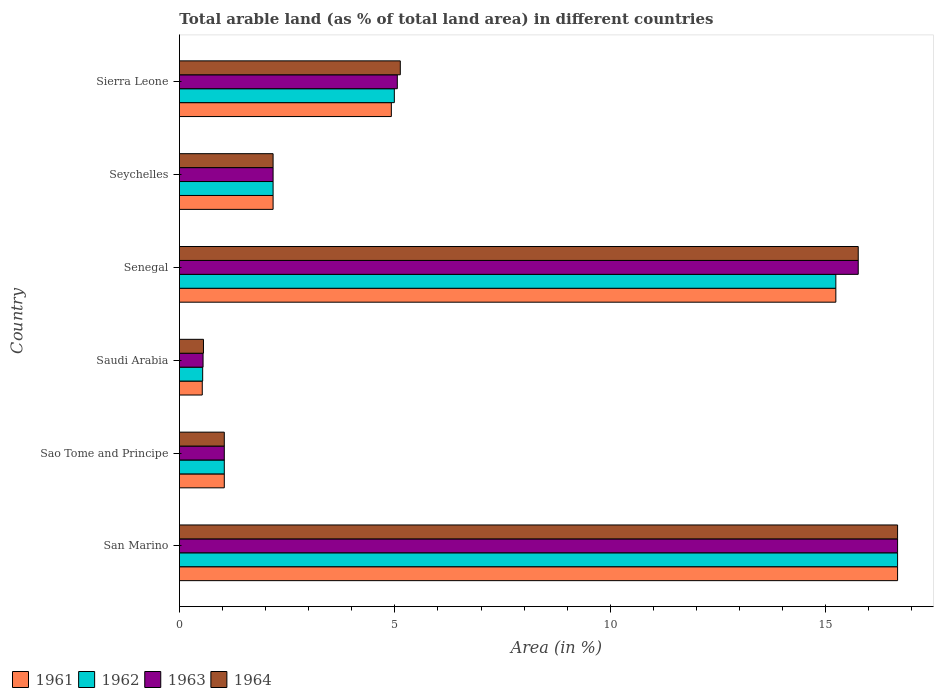How many groups of bars are there?
Your answer should be compact. 6. Are the number of bars per tick equal to the number of legend labels?
Keep it short and to the point. Yes. How many bars are there on the 4th tick from the top?
Keep it short and to the point. 4. What is the label of the 5th group of bars from the top?
Keep it short and to the point. Sao Tome and Principe. In how many cases, is the number of bars for a given country not equal to the number of legend labels?
Offer a very short reply. 0. What is the percentage of arable land in 1961 in Senegal?
Keep it short and to the point. 15.23. Across all countries, what is the maximum percentage of arable land in 1962?
Ensure brevity in your answer.  16.67. Across all countries, what is the minimum percentage of arable land in 1961?
Your answer should be very brief. 0.53. In which country was the percentage of arable land in 1962 maximum?
Ensure brevity in your answer.  San Marino. In which country was the percentage of arable land in 1963 minimum?
Keep it short and to the point. Saudi Arabia. What is the total percentage of arable land in 1964 in the graph?
Offer a very short reply. 41.32. What is the difference between the percentage of arable land in 1964 in Sao Tome and Principe and that in Seychelles?
Make the answer very short. -1.13. What is the difference between the percentage of arable land in 1962 in Sierra Leone and the percentage of arable land in 1964 in Saudi Arabia?
Offer a terse response. 4.43. What is the average percentage of arable land in 1962 per country?
Your answer should be very brief. 6.77. In how many countries, is the percentage of arable land in 1964 greater than 8 %?
Your response must be concise. 2. What is the ratio of the percentage of arable land in 1961 in Saudi Arabia to that in Seychelles?
Provide a short and direct response. 0.24. Is the percentage of arable land in 1961 in San Marino less than that in Seychelles?
Provide a succinct answer. No. Is the difference between the percentage of arable land in 1961 in San Marino and Seychelles greater than the difference between the percentage of arable land in 1964 in San Marino and Seychelles?
Your answer should be very brief. No. What is the difference between the highest and the second highest percentage of arable land in 1963?
Your response must be concise. 0.91. What is the difference between the highest and the lowest percentage of arable land in 1964?
Give a very brief answer. 16.11. In how many countries, is the percentage of arable land in 1961 greater than the average percentage of arable land in 1961 taken over all countries?
Your response must be concise. 2. Is it the case that in every country, the sum of the percentage of arable land in 1961 and percentage of arable land in 1962 is greater than the sum of percentage of arable land in 1963 and percentage of arable land in 1964?
Keep it short and to the point. No. What does the 4th bar from the top in Seychelles represents?
Give a very brief answer. 1961. What does the 4th bar from the bottom in Sierra Leone represents?
Ensure brevity in your answer.  1964. Is it the case that in every country, the sum of the percentage of arable land in 1961 and percentage of arable land in 1963 is greater than the percentage of arable land in 1962?
Your answer should be very brief. Yes. How many bars are there?
Provide a short and direct response. 24. Are all the bars in the graph horizontal?
Make the answer very short. Yes. Does the graph contain any zero values?
Your answer should be very brief. No. Where does the legend appear in the graph?
Your response must be concise. Bottom left. How many legend labels are there?
Offer a terse response. 4. How are the legend labels stacked?
Provide a succinct answer. Horizontal. What is the title of the graph?
Your answer should be compact. Total arable land (as % of total land area) in different countries. Does "1980" appear as one of the legend labels in the graph?
Make the answer very short. No. What is the label or title of the X-axis?
Ensure brevity in your answer.  Area (in %). What is the label or title of the Y-axis?
Keep it short and to the point. Country. What is the Area (in %) of 1961 in San Marino?
Your answer should be very brief. 16.67. What is the Area (in %) of 1962 in San Marino?
Make the answer very short. 16.67. What is the Area (in %) in 1963 in San Marino?
Your response must be concise. 16.67. What is the Area (in %) of 1964 in San Marino?
Give a very brief answer. 16.67. What is the Area (in %) of 1961 in Sao Tome and Principe?
Keep it short and to the point. 1.04. What is the Area (in %) in 1962 in Sao Tome and Principe?
Offer a terse response. 1.04. What is the Area (in %) in 1963 in Sao Tome and Principe?
Provide a short and direct response. 1.04. What is the Area (in %) of 1964 in Sao Tome and Principe?
Ensure brevity in your answer.  1.04. What is the Area (in %) of 1961 in Saudi Arabia?
Your answer should be very brief. 0.53. What is the Area (in %) of 1962 in Saudi Arabia?
Give a very brief answer. 0.54. What is the Area (in %) in 1963 in Saudi Arabia?
Your answer should be compact. 0.55. What is the Area (in %) in 1964 in Saudi Arabia?
Offer a very short reply. 0.56. What is the Area (in %) in 1961 in Senegal?
Provide a succinct answer. 15.23. What is the Area (in %) of 1962 in Senegal?
Offer a very short reply. 15.23. What is the Area (in %) of 1963 in Senegal?
Your answer should be compact. 15.75. What is the Area (in %) of 1964 in Senegal?
Your response must be concise. 15.75. What is the Area (in %) of 1961 in Seychelles?
Keep it short and to the point. 2.17. What is the Area (in %) of 1962 in Seychelles?
Provide a succinct answer. 2.17. What is the Area (in %) in 1963 in Seychelles?
Offer a terse response. 2.17. What is the Area (in %) of 1964 in Seychelles?
Provide a succinct answer. 2.17. What is the Area (in %) of 1961 in Sierra Leone?
Offer a very short reply. 4.92. What is the Area (in %) in 1962 in Sierra Leone?
Offer a terse response. 4.99. What is the Area (in %) in 1963 in Sierra Leone?
Your answer should be compact. 5.06. What is the Area (in %) of 1964 in Sierra Leone?
Provide a short and direct response. 5.13. Across all countries, what is the maximum Area (in %) in 1961?
Ensure brevity in your answer.  16.67. Across all countries, what is the maximum Area (in %) of 1962?
Your answer should be very brief. 16.67. Across all countries, what is the maximum Area (in %) in 1963?
Your response must be concise. 16.67. Across all countries, what is the maximum Area (in %) of 1964?
Your answer should be very brief. 16.67. Across all countries, what is the minimum Area (in %) in 1961?
Give a very brief answer. 0.53. Across all countries, what is the minimum Area (in %) in 1962?
Ensure brevity in your answer.  0.54. Across all countries, what is the minimum Area (in %) of 1963?
Offer a very short reply. 0.55. Across all countries, what is the minimum Area (in %) in 1964?
Your answer should be very brief. 0.56. What is the total Area (in %) of 1961 in the graph?
Provide a succinct answer. 40.56. What is the total Area (in %) in 1962 in the graph?
Keep it short and to the point. 40.64. What is the total Area (in %) of 1963 in the graph?
Make the answer very short. 41.24. What is the total Area (in %) of 1964 in the graph?
Offer a very short reply. 41.32. What is the difference between the Area (in %) in 1961 in San Marino and that in Sao Tome and Principe?
Ensure brevity in your answer.  15.62. What is the difference between the Area (in %) in 1962 in San Marino and that in Sao Tome and Principe?
Your response must be concise. 15.62. What is the difference between the Area (in %) of 1963 in San Marino and that in Sao Tome and Principe?
Your answer should be compact. 15.62. What is the difference between the Area (in %) of 1964 in San Marino and that in Sao Tome and Principe?
Your answer should be very brief. 15.62. What is the difference between the Area (in %) in 1961 in San Marino and that in Saudi Arabia?
Offer a terse response. 16.14. What is the difference between the Area (in %) of 1962 in San Marino and that in Saudi Arabia?
Your answer should be compact. 16.13. What is the difference between the Area (in %) in 1963 in San Marino and that in Saudi Arabia?
Give a very brief answer. 16.12. What is the difference between the Area (in %) of 1964 in San Marino and that in Saudi Arabia?
Provide a short and direct response. 16.11. What is the difference between the Area (in %) in 1961 in San Marino and that in Senegal?
Ensure brevity in your answer.  1.43. What is the difference between the Area (in %) of 1962 in San Marino and that in Senegal?
Make the answer very short. 1.43. What is the difference between the Area (in %) of 1963 in San Marino and that in Senegal?
Give a very brief answer. 0.91. What is the difference between the Area (in %) in 1964 in San Marino and that in Senegal?
Offer a terse response. 0.91. What is the difference between the Area (in %) of 1961 in San Marino and that in Seychelles?
Your answer should be very brief. 14.49. What is the difference between the Area (in %) in 1962 in San Marino and that in Seychelles?
Ensure brevity in your answer.  14.49. What is the difference between the Area (in %) in 1963 in San Marino and that in Seychelles?
Offer a terse response. 14.49. What is the difference between the Area (in %) of 1964 in San Marino and that in Seychelles?
Provide a succinct answer. 14.49. What is the difference between the Area (in %) of 1961 in San Marino and that in Sierra Leone?
Make the answer very short. 11.75. What is the difference between the Area (in %) of 1962 in San Marino and that in Sierra Leone?
Your answer should be very brief. 11.68. What is the difference between the Area (in %) of 1963 in San Marino and that in Sierra Leone?
Your response must be concise. 11.61. What is the difference between the Area (in %) in 1964 in San Marino and that in Sierra Leone?
Make the answer very short. 11.54. What is the difference between the Area (in %) of 1961 in Sao Tome and Principe and that in Saudi Arabia?
Your answer should be very brief. 0.51. What is the difference between the Area (in %) of 1962 in Sao Tome and Principe and that in Saudi Arabia?
Provide a succinct answer. 0.5. What is the difference between the Area (in %) of 1963 in Sao Tome and Principe and that in Saudi Arabia?
Offer a terse response. 0.49. What is the difference between the Area (in %) of 1964 in Sao Tome and Principe and that in Saudi Arabia?
Ensure brevity in your answer.  0.48. What is the difference between the Area (in %) in 1961 in Sao Tome and Principe and that in Senegal?
Provide a short and direct response. -14.19. What is the difference between the Area (in %) in 1962 in Sao Tome and Principe and that in Senegal?
Your answer should be compact. -14.19. What is the difference between the Area (in %) of 1963 in Sao Tome and Principe and that in Senegal?
Make the answer very short. -14.71. What is the difference between the Area (in %) in 1964 in Sao Tome and Principe and that in Senegal?
Make the answer very short. -14.71. What is the difference between the Area (in %) of 1961 in Sao Tome and Principe and that in Seychelles?
Provide a succinct answer. -1.13. What is the difference between the Area (in %) in 1962 in Sao Tome and Principe and that in Seychelles?
Offer a terse response. -1.13. What is the difference between the Area (in %) of 1963 in Sao Tome and Principe and that in Seychelles?
Provide a succinct answer. -1.13. What is the difference between the Area (in %) of 1964 in Sao Tome and Principe and that in Seychelles?
Offer a very short reply. -1.13. What is the difference between the Area (in %) in 1961 in Sao Tome and Principe and that in Sierra Leone?
Your answer should be very brief. -3.88. What is the difference between the Area (in %) of 1962 in Sao Tome and Principe and that in Sierra Leone?
Provide a short and direct response. -3.95. What is the difference between the Area (in %) in 1963 in Sao Tome and Principe and that in Sierra Leone?
Keep it short and to the point. -4.02. What is the difference between the Area (in %) in 1964 in Sao Tome and Principe and that in Sierra Leone?
Your response must be concise. -4.08. What is the difference between the Area (in %) in 1961 in Saudi Arabia and that in Senegal?
Make the answer very short. -14.7. What is the difference between the Area (in %) of 1962 in Saudi Arabia and that in Senegal?
Provide a short and direct response. -14.69. What is the difference between the Area (in %) of 1963 in Saudi Arabia and that in Senegal?
Your answer should be compact. -15.2. What is the difference between the Area (in %) in 1964 in Saudi Arabia and that in Senegal?
Your answer should be very brief. -15.2. What is the difference between the Area (in %) in 1961 in Saudi Arabia and that in Seychelles?
Your answer should be very brief. -1.64. What is the difference between the Area (in %) in 1962 in Saudi Arabia and that in Seychelles?
Offer a terse response. -1.63. What is the difference between the Area (in %) of 1963 in Saudi Arabia and that in Seychelles?
Your answer should be very brief. -1.62. What is the difference between the Area (in %) of 1964 in Saudi Arabia and that in Seychelles?
Make the answer very short. -1.62. What is the difference between the Area (in %) of 1961 in Saudi Arabia and that in Sierra Leone?
Give a very brief answer. -4.39. What is the difference between the Area (in %) of 1962 in Saudi Arabia and that in Sierra Leone?
Give a very brief answer. -4.45. What is the difference between the Area (in %) of 1963 in Saudi Arabia and that in Sierra Leone?
Provide a short and direct response. -4.51. What is the difference between the Area (in %) in 1964 in Saudi Arabia and that in Sierra Leone?
Your answer should be compact. -4.57. What is the difference between the Area (in %) of 1961 in Senegal and that in Seychelles?
Provide a succinct answer. 13.06. What is the difference between the Area (in %) in 1962 in Senegal and that in Seychelles?
Offer a terse response. 13.06. What is the difference between the Area (in %) of 1963 in Senegal and that in Seychelles?
Provide a succinct answer. 13.58. What is the difference between the Area (in %) in 1964 in Senegal and that in Seychelles?
Keep it short and to the point. 13.58. What is the difference between the Area (in %) of 1961 in Senegal and that in Sierra Leone?
Offer a very short reply. 10.32. What is the difference between the Area (in %) in 1962 in Senegal and that in Sierra Leone?
Provide a succinct answer. 10.25. What is the difference between the Area (in %) in 1963 in Senegal and that in Sierra Leone?
Provide a succinct answer. 10.7. What is the difference between the Area (in %) of 1964 in Senegal and that in Sierra Leone?
Ensure brevity in your answer.  10.63. What is the difference between the Area (in %) of 1961 in Seychelles and that in Sierra Leone?
Ensure brevity in your answer.  -2.74. What is the difference between the Area (in %) in 1962 in Seychelles and that in Sierra Leone?
Provide a succinct answer. -2.81. What is the difference between the Area (in %) of 1963 in Seychelles and that in Sierra Leone?
Offer a very short reply. -2.88. What is the difference between the Area (in %) in 1964 in Seychelles and that in Sierra Leone?
Keep it short and to the point. -2.95. What is the difference between the Area (in %) in 1961 in San Marino and the Area (in %) in 1962 in Sao Tome and Principe?
Offer a terse response. 15.62. What is the difference between the Area (in %) in 1961 in San Marino and the Area (in %) in 1963 in Sao Tome and Principe?
Your response must be concise. 15.62. What is the difference between the Area (in %) in 1961 in San Marino and the Area (in %) in 1964 in Sao Tome and Principe?
Your answer should be compact. 15.62. What is the difference between the Area (in %) of 1962 in San Marino and the Area (in %) of 1963 in Sao Tome and Principe?
Offer a very short reply. 15.62. What is the difference between the Area (in %) of 1962 in San Marino and the Area (in %) of 1964 in Sao Tome and Principe?
Ensure brevity in your answer.  15.62. What is the difference between the Area (in %) in 1963 in San Marino and the Area (in %) in 1964 in Sao Tome and Principe?
Make the answer very short. 15.62. What is the difference between the Area (in %) in 1961 in San Marino and the Area (in %) in 1962 in Saudi Arabia?
Your response must be concise. 16.13. What is the difference between the Area (in %) in 1961 in San Marino and the Area (in %) in 1963 in Saudi Arabia?
Give a very brief answer. 16.12. What is the difference between the Area (in %) of 1961 in San Marino and the Area (in %) of 1964 in Saudi Arabia?
Provide a short and direct response. 16.11. What is the difference between the Area (in %) in 1962 in San Marino and the Area (in %) in 1963 in Saudi Arabia?
Make the answer very short. 16.12. What is the difference between the Area (in %) of 1962 in San Marino and the Area (in %) of 1964 in Saudi Arabia?
Provide a short and direct response. 16.11. What is the difference between the Area (in %) in 1963 in San Marino and the Area (in %) in 1964 in Saudi Arabia?
Ensure brevity in your answer.  16.11. What is the difference between the Area (in %) of 1961 in San Marino and the Area (in %) of 1962 in Senegal?
Keep it short and to the point. 1.43. What is the difference between the Area (in %) of 1961 in San Marino and the Area (in %) of 1963 in Senegal?
Provide a succinct answer. 0.91. What is the difference between the Area (in %) in 1961 in San Marino and the Area (in %) in 1964 in Senegal?
Offer a very short reply. 0.91. What is the difference between the Area (in %) in 1962 in San Marino and the Area (in %) in 1963 in Senegal?
Give a very brief answer. 0.91. What is the difference between the Area (in %) of 1962 in San Marino and the Area (in %) of 1964 in Senegal?
Offer a very short reply. 0.91. What is the difference between the Area (in %) of 1963 in San Marino and the Area (in %) of 1964 in Senegal?
Keep it short and to the point. 0.91. What is the difference between the Area (in %) of 1961 in San Marino and the Area (in %) of 1962 in Seychelles?
Offer a terse response. 14.49. What is the difference between the Area (in %) in 1961 in San Marino and the Area (in %) in 1963 in Seychelles?
Your answer should be compact. 14.49. What is the difference between the Area (in %) of 1961 in San Marino and the Area (in %) of 1964 in Seychelles?
Ensure brevity in your answer.  14.49. What is the difference between the Area (in %) in 1962 in San Marino and the Area (in %) in 1963 in Seychelles?
Provide a short and direct response. 14.49. What is the difference between the Area (in %) in 1962 in San Marino and the Area (in %) in 1964 in Seychelles?
Make the answer very short. 14.49. What is the difference between the Area (in %) of 1963 in San Marino and the Area (in %) of 1964 in Seychelles?
Provide a short and direct response. 14.49. What is the difference between the Area (in %) of 1961 in San Marino and the Area (in %) of 1962 in Sierra Leone?
Offer a terse response. 11.68. What is the difference between the Area (in %) of 1961 in San Marino and the Area (in %) of 1963 in Sierra Leone?
Keep it short and to the point. 11.61. What is the difference between the Area (in %) in 1961 in San Marino and the Area (in %) in 1964 in Sierra Leone?
Give a very brief answer. 11.54. What is the difference between the Area (in %) of 1962 in San Marino and the Area (in %) of 1963 in Sierra Leone?
Offer a very short reply. 11.61. What is the difference between the Area (in %) of 1962 in San Marino and the Area (in %) of 1964 in Sierra Leone?
Make the answer very short. 11.54. What is the difference between the Area (in %) of 1963 in San Marino and the Area (in %) of 1964 in Sierra Leone?
Your answer should be very brief. 11.54. What is the difference between the Area (in %) of 1961 in Sao Tome and Principe and the Area (in %) of 1962 in Saudi Arabia?
Provide a short and direct response. 0.5. What is the difference between the Area (in %) in 1961 in Sao Tome and Principe and the Area (in %) in 1963 in Saudi Arabia?
Your answer should be very brief. 0.49. What is the difference between the Area (in %) in 1961 in Sao Tome and Principe and the Area (in %) in 1964 in Saudi Arabia?
Your answer should be compact. 0.48. What is the difference between the Area (in %) in 1962 in Sao Tome and Principe and the Area (in %) in 1963 in Saudi Arabia?
Keep it short and to the point. 0.49. What is the difference between the Area (in %) of 1962 in Sao Tome and Principe and the Area (in %) of 1964 in Saudi Arabia?
Your answer should be very brief. 0.48. What is the difference between the Area (in %) in 1963 in Sao Tome and Principe and the Area (in %) in 1964 in Saudi Arabia?
Your answer should be compact. 0.48. What is the difference between the Area (in %) of 1961 in Sao Tome and Principe and the Area (in %) of 1962 in Senegal?
Offer a very short reply. -14.19. What is the difference between the Area (in %) in 1961 in Sao Tome and Principe and the Area (in %) in 1963 in Senegal?
Ensure brevity in your answer.  -14.71. What is the difference between the Area (in %) in 1961 in Sao Tome and Principe and the Area (in %) in 1964 in Senegal?
Keep it short and to the point. -14.71. What is the difference between the Area (in %) in 1962 in Sao Tome and Principe and the Area (in %) in 1963 in Senegal?
Give a very brief answer. -14.71. What is the difference between the Area (in %) in 1962 in Sao Tome and Principe and the Area (in %) in 1964 in Senegal?
Make the answer very short. -14.71. What is the difference between the Area (in %) in 1963 in Sao Tome and Principe and the Area (in %) in 1964 in Senegal?
Keep it short and to the point. -14.71. What is the difference between the Area (in %) in 1961 in Sao Tome and Principe and the Area (in %) in 1962 in Seychelles?
Provide a short and direct response. -1.13. What is the difference between the Area (in %) of 1961 in Sao Tome and Principe and the Area (in %) of 1963 in Seychelles?
Your answer should be compact. -1.13. What is the difference between the Area (in %) in 1961 in Sao Tome and Principe and the Area (in %) in 1964 in Seychelles?
Your response must be concise. -1.13. What is the difference between the Area (in %) in 1962 in Sao Tome and Principe and the Area (in %) in 1963 in Seychelles?
Ensure brevity in your answer.  -1.13. What is the difference between the Area (in %) in 1962 in Sao Tome and Principe and the Area (in %) in 1964 in Seychelles?
Provide a succinct answer. -1.13. What is the difference between the Area (in %) in 1963 in Sao Tome and Principe and the Area (in %) in 1964 in Seychelles?
Offer a terse response. -1.13. What is the difference between the Area (in %) of 1961 in Sao Tome and Principe and the Area (in %) of 1962 in Sierra Leone?
Provide a succinct answer. -3.95. What is the difference between the Area (in %) of 1961 in Sao Tome and Principe and the Area (in %) of 1963 in Sierra Leone?
Your answer should be compact. -4.02. What is the difference between the Area (in %) in 1961 in Sao Tome and Principe and the Area (in %) in 1964 in Sierra Leone?
Your answer should be compact. -4.08. What is the difference between the Area (in %) of 1962 in Sao Tome and Principe and the Area (in %) of 1963 in Sierra Leone?
Provide a succinct answer. -4.02. What is the difference between the Area (in %) in 1962 in Sao Tome and Principe and the Area (in %) in 1964 in Sierra Leone?
Offer a terse response. -4.08. What is the difference between the Area (in %) in 1963 in Sao Tome and Principe and the Area (in %) in 1964 in Sierra Leone?
Your answer should be very brief. -4.08. What is the difference between the Area (in %) in 1961 in Saudi Arabia and the Area (in %) in 1962 in Senegal?
Keep it short and to the point. -14.7. What is the difference between the Area (in %) of 1961 in Saudi Arabia and the Area (in %) of 1963 in Senegal?
Provide a succinct answer. -15.22. What is the difference between the Area (in %) in 1961 in Saudi Arabia and the Area (in %) in 1964 in Senegal?
Provide a succinct answer. -15.22. What is the difference between the Area (in %) in 1962 in Saudi Arabia and the Area (in %) in 1963 in Senegal?
Your answer should be very brief. -15.21. What is the difference between the Area (in %) of 1962 in Saudi Arabia and the Area (in %) of 1964 in Senegal?
Keep it short and to the point. -15.21. What is the difference between the Area (in %) of 1963 in Saudi Arabia and the Area (in %) of 1964 in Senegal?
Provide a short and direct response. -15.2. What is the difference between the Area (in %) of 1961 in Saudi Arabia and the Area (in %) of 1962 in Seychelles?
Keep it short and to the point. -1.64. What is the difference between the Area (in %) of 1961 in Saudi Arabia and the Area (in %) of 1963 in Seychelles?
Keep it short and to the point. -1.64. What is the difference between the Area (in %) in 1961 in Saudi Arabia and the Area (in %) in 1964 in Seychelles?
Make the answer very short. -1.64. What is the difference between the Area (in %) of 1962 in Saudi Arabia and the Area (in %) of 1963 in Seychelles?
Keep it short and to the point. -1.63. What is the difference between the Area (in %) of 1962 in Saudi Arabia and the Area (in %) of 1964 in Seychelles?
Ensure brevity in your answer.  -1.63. What is the difference between the Area (in %) in 1963 in Saudi Arabia and the Area (in %) in 1964 in Seychelles?
Your answer should be very brief. -1.62. What is the difference between the Area (in %) of 1961 in Saudi Arabia and the Area (in %) of 1962 in Sierra Leone?
Keep it short and to the point. -4.46. What is the difference between the Area (in %) of 1961 in Saudi Arabia and the Area (in %) of 1963 in Sierra Leone?
Your response must be concise. -4.53. What is the difference between the Area (in %) in 1961 in Saudi Arabia and the Area (in %) in 1964 in Sierra Leone?
Offer a terse response. -4.6. What is the difference between the Area (in %) of 1962 in Saudi Arabia and the Area (in %) of 1963 in Sierra Leone?
Offer a terse response. -4.52. What is the difference between the Area (in %) in 1962 in Saudi Arabia and the Area (in %) in 1964 in Sierra Leone?
Provide a short and direct response. -4.59. What is the difference between the Area (in %) in 1963 in Saudi Arabia and the Area (in %) in 1964 in Sierra Leone?
Ensure brevity in your answer.  -4.58. What is the difference between the Area (in %) of 1961 in Senegal and the Area (in %) of 1962 in Seychelles?
Your answer should be very brief. 13.06. What is the difference between the Area (in %) in 1961 in Senegal and the Area (in %) in 1963 in Seychelles?
Provide a short and direct response. 13.06. What is the difference between the Area (in %) of 1961 in Senegal and the Area (in %) of 1964 in Seychelles?
Give a very brief answer. 13.06. What is the difference between the Area (in %) of 1962 in Senegal and the Area (in %) of 1963 in Seychelles?
Your answer should be compact. 13.06. What is the difference between the Area (in %) in 1962 in Senegal and the Area (in %) in 1964 in Seychelles?
Your response must be concise. 13.06. What is the difference between the Area (in %) of 1963 in Senegal and the Area (in %) of 1964 in Seychelles?
Provide a succinct answer. 13.58. What is the difference between the Area (in %) of 1961 in Senegal and the Area (in %) of 1962 in Sierra Leone?
Make the answer very short. 10.25. What is the difference between the Area (in %) of 1961 in Senegal and the Area (in %) of 1963 in Sierra Leone?
Keep it short and to the point. 10.18. What is the difference between the Area (in %) in 1961 in Senegal and the Area (in %) in 1964 in Sierra Leone?
Provide a succinct answer. 10.11. What is the difference between the Area (in %) of 1962 in Senegal and the Area (in %) of 1963 in Sierra Leone?
Keep it short and to the point. 10.18. What is the difference between the Area (in %) of 1962 in Senegal and the Area (in %) of 1964 in Sierra Leone?
Your answer should be compact. 10.11. What is the difference between the Area (in %) of 1963 in Senegal and the Area (in %) of 1964 in Sierra Leone?
Make the answer very short. 10.63. What is the difference between the Area (in %) in 1961 in Seychelles and the Area (in %) in 1962 in Sierra Leone?
Offer a very short reply. -2.81. What is the difference between the Area (in %) of 1961 in Seychelles and the Area (in %) of 1963 in Sierra Leone?
Give a very brief answer. -2.88. What is the difference between the Area (in %) in 1961 in Seychelles and the Area (in %) in 1964 in Sierra Leone?
Your answer should be very brief. -2.95. What is the difference between the Area (in %) of 1962 in Seychelles and the Area (in %) of 1963 in Sierra Leone?
Your response must be concise. -2.88. What is the difference between the Area (in %) in 1962 in Seychelles and the Area (in %) in 1964 in Sierra Leone?
Provide a succinct answer. -2.95. What is the difference between the Area (in %) in 1963 in Seychelles and the Area (in %) in 1964 in Sierra Leone?
Offer a very short reply. -2.95. What is the average Area (in %) in 1961 per country?
Give a very brief answer. 6.76. What is the average Area (in %) in 1962 per country?
Offer a very short reply. 6.77. What is the average Area (in %) of 1963 per country?
Offer a very short reply. 6.87. What is the average Area (in %) in 1964 per country?
Your response must be concise. 6.89. What is the difference between the Area (in %) of 1961 and Area (in %) of 1962 in San Marino?
Provide a succinct answer. 0. What is the difference between the Area (in %) of 1961 and Area (in %) of 1963 in San Marino?
Give a very brief answer. 0. What is the difference between the Area (in %) of 1961 and Area (in %) of 1964 in San Marino?
Provide a succinct answer. 0. What is the difference between the Area (in %) in 1961 and Area (in %) in 1962 in Sao Tome and Principe?
Provide a succinct answer. 0. What is the difference between the Area (in %) in 1962 and Area (in %) in 1963 in Sao Tome and Principe?
Offer a terse response. 0. What is the difference between the Area (in %) in 1962 and Area (in %) in 1964 in Sao Tome and Principe?
Provide a short and direct response. 0. What is the difference between the Area (in %) in 1961 and Area (in %) in 1962 in Saudi Arabia?
Offer a very short reply. -0.01. What is the difference between the Area (in %) of 1961 and Area (in %) of 1963 in Saudi Arabia?
Ensure brevity in your answer.  -0.02. What is the difference between the Area (in %) in 1961 and Area (in %) in 1964 in Saudi Arabia?
Make the answer very short. -0.03. What is the difference between the Area (in %) of 1962 and Area (in %) of 1963 in Saudi Arabia?
Offer a very short reply. -0.01. What is the difference between the Area (in %) in 1962 and Area (in %) in 1964 in Saudi Arabia?
Make the answer very short. -0.02. What is the difference between the Area (in %) in 1963 and Area (in %) in 1964 in Saudi Arabia?
Make the answer very short. -0.01. What is the difference between the Area (in %) in 1961 and Area (in %) in 1963 in Senegal?
Provide a succinct answer. -0.52. What is the difference between the Area (in %) in 1961 and Area (in %) in 1964 in Senegal?
Offer a very short reply. -0.52. What is the difference between the Area (in %) of 1962 and Area (in %) of 1963 in Senegal?
Keep it short and to the point. -0.52. What is the difference between the Area (in %) of 1962 and Area (in %) of 1964 in Senegal?
Your answer should be compact. -0.52. What is the difference between the Area (in %) in 1963 and Area (in %) in 1964 in Senegal?
Offer a very short reply. 0. What is the difference between the Area (in %) of 1961 and Area (in %) of 1963 in Seychelles?
Provide a succinct answer. 0. What is the difference between the Area (in %) of 1961 and Area (in %) of 1964 in Seychelles?
Give a very brief answer. 0. What is the difference between the Area (in %) in 1962 and Area (in %) in 1964 in Seychelles?
Your response must be concise. 0. What is the difference between the Area (in %) in 1961 and Area (in %) in 1962 in Sierra Leone?
Keep it short and to the point. -0.07. What is the difference between the Area (in %) of 1961 and Area (in %) of 1963 in Sierra Leone?
Provide a short and direct response. -0.14. What is the difference between the Area (in %) of 1961 and Area (in %) of 1964 in Sierra Leone?
Your response must be concise. -0.21. What is the difference between the Area (in %) of 1962 and Area (in %) of 1963 in Sierra Leone?
Ensure brevity in your answer.  -0.07. What is the difference between the Area (in %) of 1962 and Area (in %) of 1964 in Sierra Leone?
Make the answer very short. -0.14. What is the difference between the Area (in %) in 1963 and Area (in %) in 1964 in Sierra Leone?
Your answer should be very brief. -0.07. What is the ratio of the Area (in %) of 1961 in San Marino to that in Sao Tome and Principe?
Provide a succinct answer. 16. What is the ratio of the Area (in %) of 1963 in San Marino to that in Sao Tome and Principe?
Keep it short and to the point. 16. What is the ratio of the Area (in %) of 1964 in San Marino to that in Sao Tome and Principe?
Provide a short and direct response. 16. What is the ratio of the Area (in %) of 1961 in San Marino to that in Saudi Arabia?
Keep it short and to the point. 31.43. What is the ratio of the Area (in %) in 1962 in San Marino to that in Saudi Arabia?
Offer a very short reply. 30.89. What is the ratio of the Area (in %) in 1963 in San Marino to that in Saudi Arabia?
Give a very brief answer. 30.36. What is the ratio of the Area (in %) of 1964 in San Marino to that in Saudi Arabia?
Provide a succinct answer. 29.86. What is the ratio of the Area (in %) of 1961 in San Marino to that in Senegal?
Offer a terse response. 1.09. What is the ratio of the Area (in %) of 1962 in San Marino to that in Senegal?
Keep it short and to the point. 1.09. What is the ratio of the Area (in %) of 1963 in San Marino to that in Senegal?
Give a very brief answer. 1.06. What is the ratio of the Area (in %) of 1964 in San Marino to that in Senegal?
Offer a very short reply. 1.06. What is the ratio of the Area (in %) of 1961 in San Marino to that in Seychelles?
Give a very brief answer. 7.67. What is the ratio of the Area (in %) of 1962 in San Marino to that in Seychelles?
Offer a very short reply. 7.67. What is the ratio of the Area (in %) of 1963 in San Marino to that in Seychelles?
Provide a succinct answer. 7.67. What is the ratio of the Area (in %) in 1964 in San Marino to that in Seychelles?
Offer a terse response. 7.67. What is the ratio of the Area (in %) in 1961 in San Marino to that in Sierra Leone?
Provide a short and direct response. 3.39. What is the ratio of the Area (in %) of 1962 in San Marino to that in Sierra Leone?
Provide a short and direct response. 3.34. What is the ratio of the Area (in %) of 1963 in San Marino to that in Sierra Leone?
Your response must be concise. 3.3. What is the ratio of the Area (in %) in 1964 in San Marino to that in Sierra Leone?
Keep it short and to the point. 3.25. What is the ratio of the Area (in %) of 1961 in Sao Tome and Principe to that in Saudi Arabia?
Give a very brief answer. 1.96. What is the ratio of the Area (in %) of 1962 in Sao Tome and Principe to that in Saudi Arabia?
Your answer should be compact. 1.93. What is the ratio of the Area (in %) of 1963 in Sao Tome and Principe to that in Saudi Arabia?
Give a very brief answer. 1.9. What is the ratio of the Area (in %) of 1964 in Sao Tome and Principe to that in Saudi Arabia?
Give a very brief answer. 1.87. What is the ratio of the Area (in %) of 1961 in Sao Tome and Principe to that in Senegal?
Provide a succinct answer. 0.07. What is the ratio of the Area (in %) of 1962 in Sao Tome and Principe to that in Senegal?
Offer a terse response. 0.07. What is the ratio of the Area (in %) of 1963 in Sao Tome and Principe to that in Senegal?
Provide a short and direct response. 0.07. What is the ratio of the Area (in %) of 1964 in Sao Tome and Principe to that in Senegal?
Give a very brief answer. 0.07. What is the ratio of the Area (in %) in 1961 in Sao Tome and Principe to that in Seychelles?
Make the answer very short. 0.48. What is the ratio of the Area (in %) in 1962 in Sao Tome and Principe to that in Seychelles?
Provide a succinct answer. 0.48. What is the ratio of the Area (in %) of 1963 in Sao Tome and Principe to that in Seychelles?
Give a very brief answer. 0.48. What is the ratio of the Area (in %) in 1964 in Sao Tome and Principe to that in Seychelles?
Offer a terse response. 0.48. What is the ratio of the Area (in %) of 1961 in Sao Tome and Principe to that in Sierra Leone?
Provide a short and direct response. 0.21. What is the ratio of the Area (in %) in 1962 in Sao Tome and Principe to that in Sierra Leone?
Your response must be concise. 0.21. What is the ratio of the Area (in %) in 1963 in Sao Tome and Principe to that in Sierra Leone?
Your answer should be compact. 0.21. What is the ratio of the Area (in %) in 1964 in Sao Tome and Principe to that in Sierra Leone?
Give a very brief answer. 0.2. What is the ratio of the Area (in %) in 1961 in Saudi Arabia to that in Senegal?
Your answer should be compact. 0.03. What is the ratio of the Area (in %) of 1962 in Saudi Arabia to that in Senegal?
Offer a terse response. 0.04. What is the ratio of the Area (in %) in 1963 in Saudi Arabia to that in Senegal?
Provide a short and direct response. 0.03. What is the ratio of the Area (in %) in 1964 in Saudi Arabia to that in Senegal?
Your answer should be very brief. 0.04. What is the ratio of the Area (in %) of 1961 in Saudi Arabia to that in Seychelles?
Keep it short and to the point. 0.24. What is the ratio of the Area (in %) in 1962 in Saudi Arabia to that in Seychelles?
Provide a succinct answer. 0.25. What is the ratio of the Area (in %) of 1963 in Saudi Arabia to that in Seychelles?
Provide a succinct answer. 0.25. What is the ratio of the Area (in %) in 1964 in Saudi Arabia to that in Seychelles?
Ensure brevity in your answer.  0.26. What is the ratio of the Area (in %) of 1961 in Saudi Arabia to that in Sierra Leone?
Make the answer very short. 0.11. What is the ratio of the Area (in %) in 1962 in Saudi Arabia to that in Sierra Leone?
Provide a succinct answer. 0.11. What is the ratio of the Area (in %) of 1963 in Saudi Arabia to that in Sierra Leone?
Offer a very short reply. 0.11. What is the ratio of the Area (in %) of 1964 in Saudi Arabia to that in Sierra Leone?
Your answer should be very brief. 0.11. What is the ratio of the Area (in %) of 1961 in Senegal to that in Seychelles?
Give a very brief answer. 7.01. What is the ratio of the Area (in %) in 1962 in Senegal to that in Seychelles?
Keep it short and to the point. 7.01. What is the ratio of the Area (in %) of 1963 in Senegal to that in Seychelles?
Provide a short and direct response. 7.25. What is the ratio of the Area (in %) in 1964 in Senegal to that in Seychelles?
Ensure brevity in your answer.  7.25. What is the ratio of the Area (in %) in 1961 in Senegal to that in Sierra Leone?
Your answer should be very brief. 3.1. What is the ratio of the Area (in %) of 1962 in Senegal to that in Sierra Leone?
Your answer should be compact. 3.05. What is the ratio of the Area (in %) of 1963 in Senegal to that in Sierra Leone?
Provide a succinct answer. 3.12. What is the ratio of the Area (in %) in 1964 in Senegal to that in Sierra Leone?
Your answer should be very brief. 3.07. What is the ratio of the Area (in %) in 1961 in Seychelles to that in Sierra Leone?
Your response must be concise. 0.44. What is the ratio of the Area (in %) in 1962 in Seychelles to that in Sierra Leone?
Offer a very short reply. 0.44. What is the ratio of the Area (in %) in 1963 in Seychelles to that in Sierra Leone?
Ensure brevity in your answer.  0.43. What is the ratio of the Area (in %) of 1964 in Seychelles to that in Sierra Leone?
Provide a short and direct response. 0.42. What is the difference between the highest and the second highest Area (in %) in 1961?
Provide a short and direct response. 1.43. What is the difference between the highest and the second highest Area (in %) of 1962?
Your answer should be very brief. 1.43. What is the difference between the highest and the second highest Area (in %) in 1963?
Make the answer very short. 0.91. What is the difference between the highest and the second highest Area (in %) of 1964?
Offer a terse response. 0.91. What is the difference between the highest and the lowest Area (in %) of 1961?
Your response must be concise. 16.14. What is the difference between the highest and the lowest Area (in %) of 1962?
Make the answer very short. 16.13. What is the difference between the highest and the lowest Area (in %) of 1963?
Your response must be concise. 16.12. What is the difference between the highest and the lowest Area (in %) in 1964?
Make the answer very short. 16.11. 